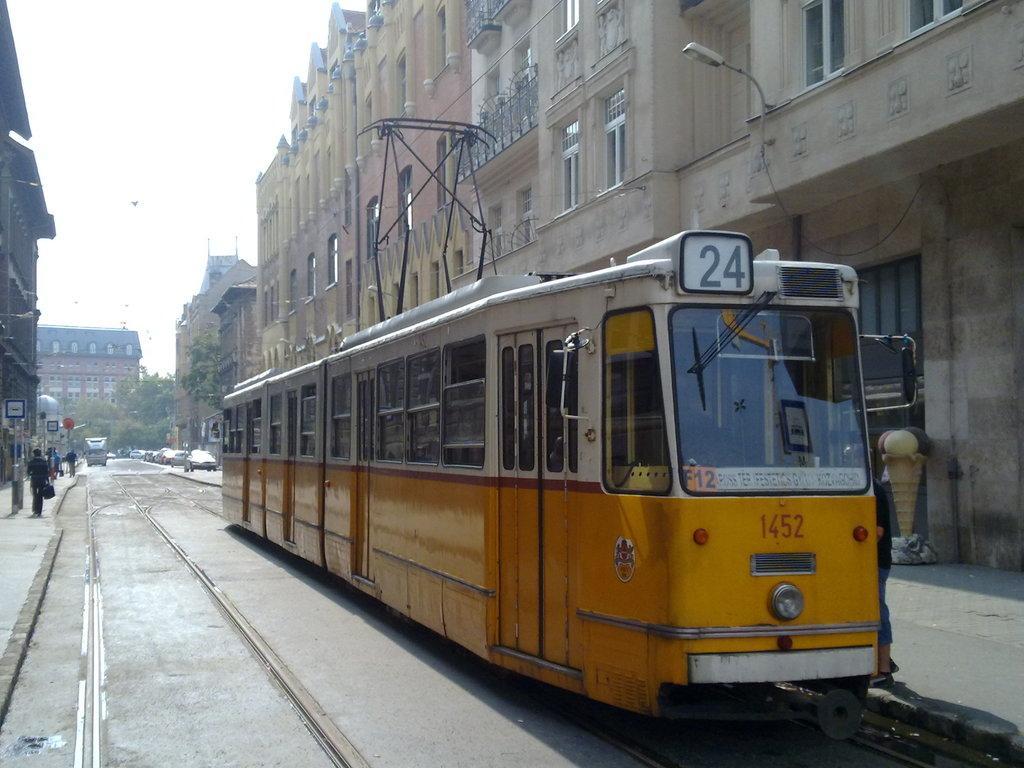Please provide a concise description of this image. This is an outside view. In the middle of the image there is a train on the track. On the left side few people are walking on the footpath. In the background there are many vehicles on the road. On the right and left side of the image there are many buildings. In the background there are many trees. At the top of the image I can see the sky. 